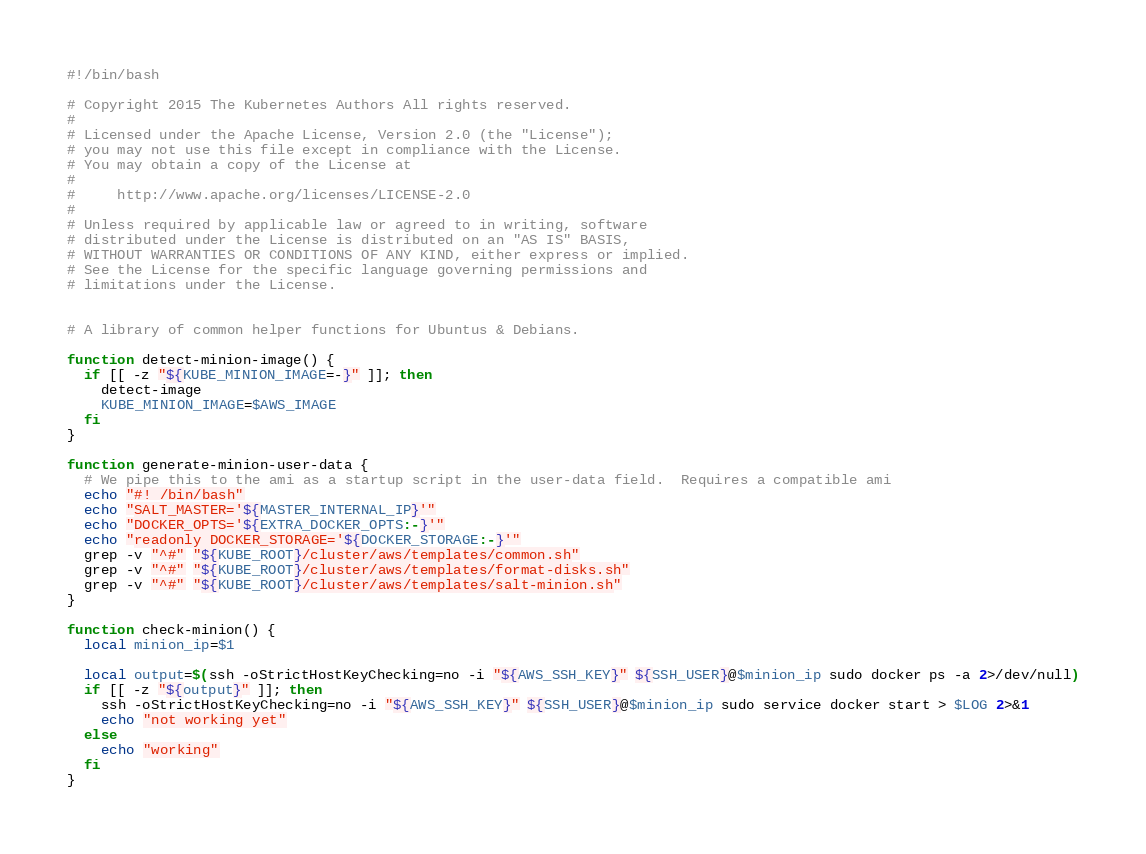<code> <loc_0><loc_0><loc_500><loc_500><_Bash_>#!/bin/bash

# Copyright 2015 The Kubernetes Authors All rights reserved.
#
# Licensed under the Apache License, Version 2.0 (the "License");
# you may not use this file except in compliance with the License.
# You may obtain a copy of the License at
#
#     http://www.apache.org/licenses/LICENSE-2.0
#
# Unless required by applicable law or agreed to in writing, software
# distributed under the License is distributed on an "AS IS" BASIS,
# WITHOUT WARRANTIES OR CONDITIONS OF ANY KIND, either express or implied.
# See the License for the specific language governing permissions and
# limitations under the License.


# A library of common helper functions for Ubuntus & Debians.

function detect-minion-image() {
  if [[ -z "${KUBE_MINION_IMAGE=-}" ]]; then
    detect-image
    KUBE_MINION_IMAGE=$AWS_IMAGE
  fi
}

function generate-minion-user-data {
  # We pipe this to the ami as a startup script in the user-data field.  Requires a compatible ami
  echo "#! /bin/bash"
  echo "SALT_MASTER='${MASTER_INTERNAL_IP}'"
  echo "DOCKER_OPTS='${EXTRA_DOCKER_OPTS:-}'"
  echo "readonly DOCKER_STORAGE='${DOCKER_STORAGE:-}'"
  grep -v "^#" "${KUBE_ROOT}/cluster/aws/templates/common.sh"
  grep -v "^#" "${KUBE_ROOT}/cluster/aws/templates/format-disks.sh"
  grep -v "^#" "${KUBE_ROOT}/cluster/aws/templates/salt-minion.sh"
}

function check-minion() {
  local minion_ip=$1

  local output=$(ssh -oStrictHostKeyChecking=no -i "${AWS_SSH_KEY}" ${SSH_USER}@$minion_ip sudo docker ps -a 2>/dev/null)
  if [[ -z "${output}" ]]; then
    ssh -oStrictHostKeyChecking=no -i "${AWS_SSH_KEY}" ${SSH_USER}@$minion_ip sudo service docker start > $LOG 2>&1
    echo "not working yet"
  else
    echo "working"
  fi
}
</code> 